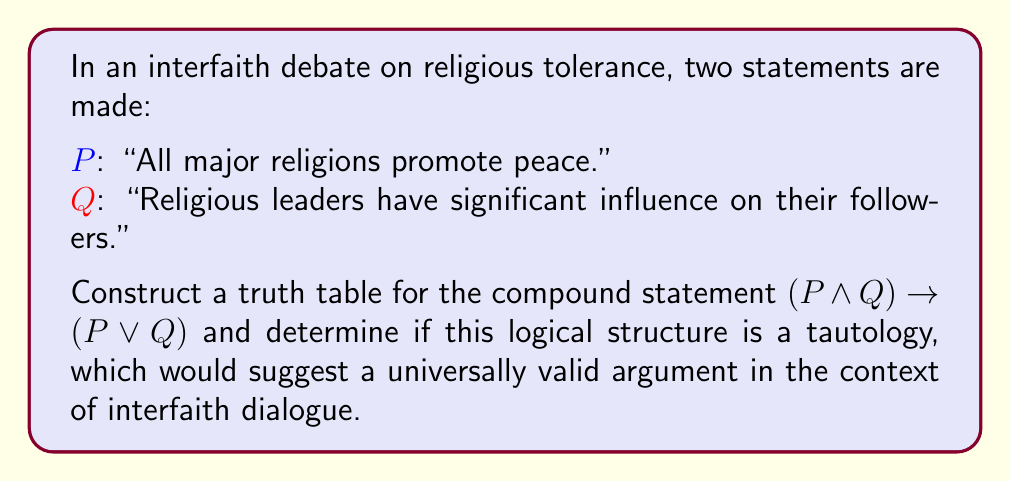Show me your answer to this math problem. To determine if the compound statement $(P \land Q) \rightarrow (P \lor Q)$ is a tautology, we need to construct a truth table and evaluate all possible combinations of truth values for P and Q.

Step 1: Identify the components of the statement
- P: "All major religions promote peace."
- Q: "Religious leaders have significant influence on their followers."
- Compound statement: $(P \land Q) \rightarrow (P \lor Q)$

Step 2: Create the truth table

$$
\begin{array}{|c|c|c|c|c|c|}
\hline
P & Q & P \land Q & P \lor Q & (P \land Q) \rightarrow (P \lor Q) \\
\hline
T & T & T & T & T \\
T & F & F & T & T \\
F & T & F & T & T \\
F & F & F & F & T \\
\hline
\end{array}
$$

Step 3: Evaluate each row
- Row 1: When both P and Q are true, $(P \land Q)$ is true, and $(P \lor Q)$ is true. The implication is true.
- Row 2: When P is true and Q is false, $(P \land Q)$ is false, but $(P \lor Q)$ is true. The implication is true.
- Row 3: When P is false and Q is true, $(P \land Q)$ is false, but $(P \lor Q)$ is true. The implication is true.
- Row 4: When both P and Q are false, $(P \land Q)$ is false, and $(P \lor Q)$ is false. The implication is still true because false implies false.

Step 4: Analyze the results
Since the final column of the truth table contains only true values, the compound statement $(P \land Q) \rightarrow (P \lor Q)$ is a tautology.

In the context of interfaith dialogue, this tautology suggests that the logical structure of the argument is universally valid, regardless of the truth values of the individual statements about religious peace promotion and leadership influence. This could be interpreted as a foundation for constructive dialogue, as it demonstrates a logical consistency in the relationship between these ideas, even if their individual truth values may be debated in different contexts or faiths.
Answer: Tautology 